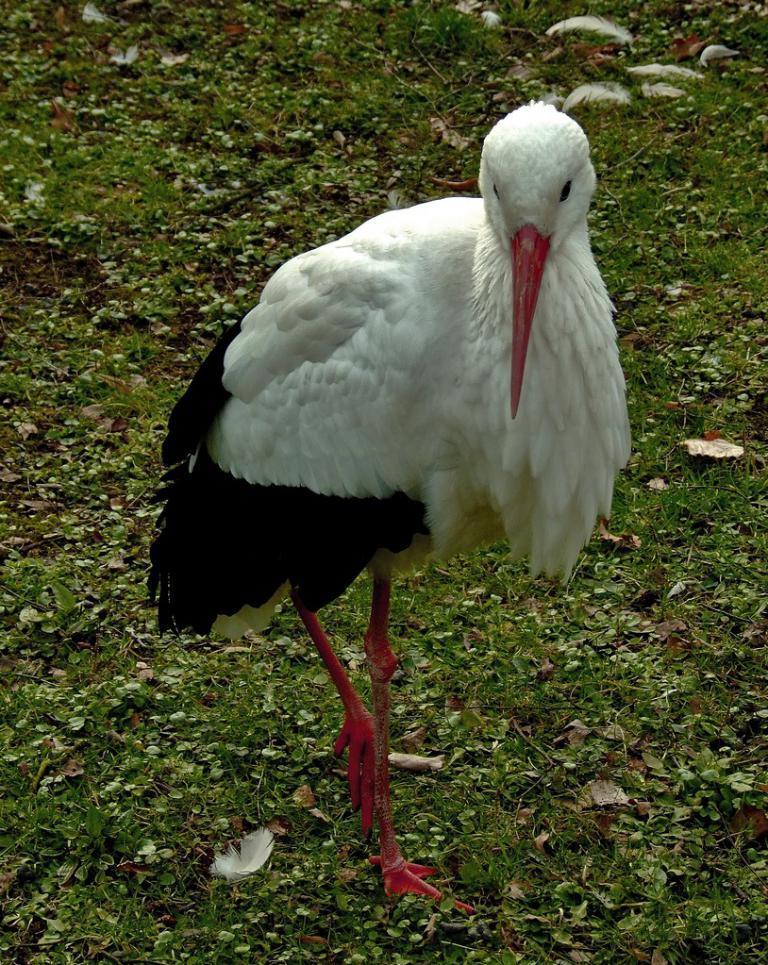Please provide a concise description of this image. In this image, I can see a white stork standing. This is the grass, which is green in color. 